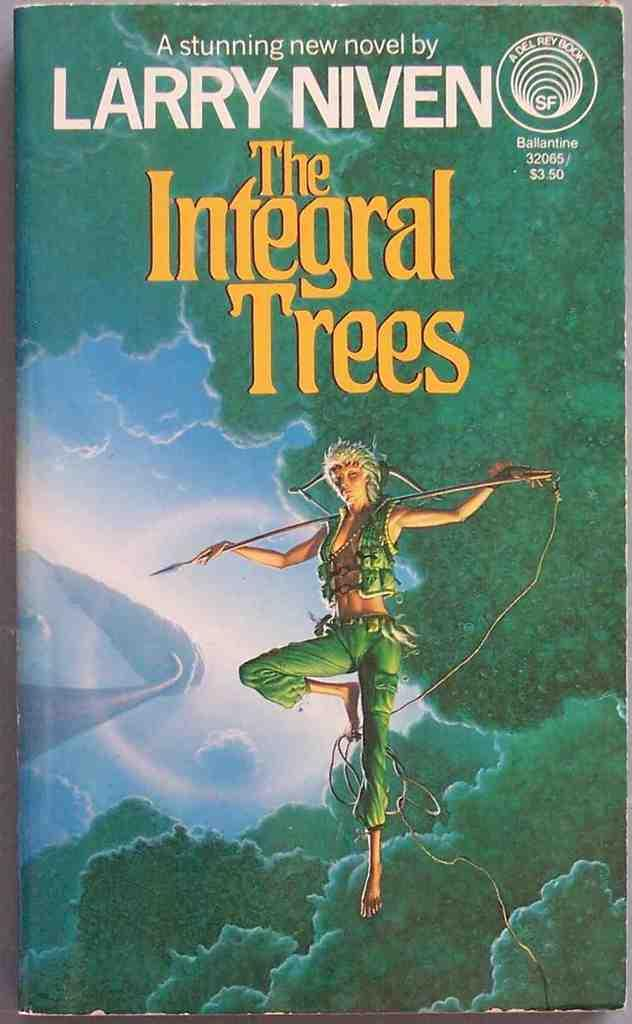<image>
Provide a brief description of the given image. The Integral Trees by Larry Niven sits on a table. 